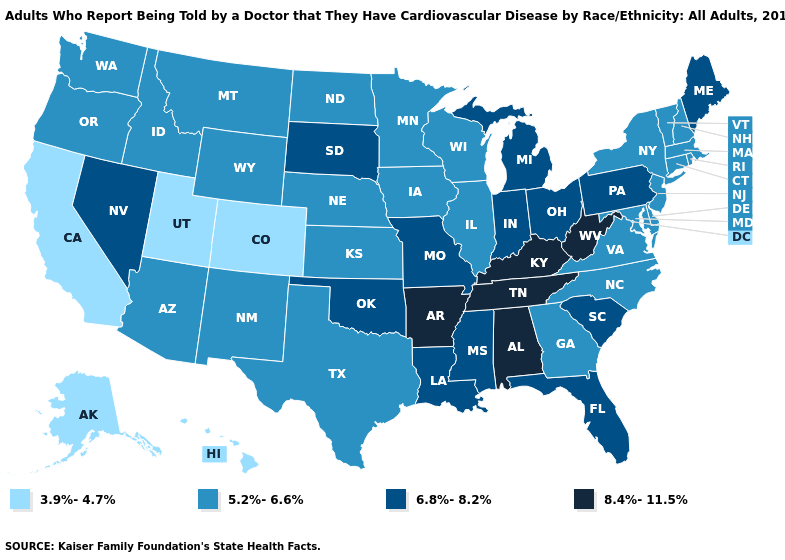Does the first symbol in the legend represent the smallest category?
Concise answer only. Yes. What is the highest value in states that border Michigan?
Give a very brief answer. 6.8%-8.2%. Does Texas have the same value as Indiana?
Write a very short answer. No. Name the states that have a value in the range 5.2%-6.6%?
Keep it brief. Arizona, Connecticut, Delaware, Georgia, Idaho, Illinois, Iowa, Kansas, Maryland, Massachusetts, Minnesota, Montana, Nebraska, New Hampshire, New Jersey, New Mexico, New York, North Carolina, North Dakota, Oregon, Rhode Island, Texas, Vermont, Virginia, Washington, Wisconsin, Wyoming. Name the states that have a value in the range 8.4%-11.5%?
Keep it brief. Alabama, Arkansas, Kentucky, Tennessee, West Virginia. Does North Dakota have the lowest value in the USA?
Answer briefly. No. What is the value of Mississippi?
Short answer required. 6.8%-8.2%. What is the highest value in the West ?
Be succinct. 6.8%-8.2%. Does Hawaii have the lowest value in the West?
Short answer required. Yes. What is the value of Minnesota?
Quick response, please. 5.2%-6.6%. Does Colorado have the lowest value in the West?
Short answer required. Yes. What is the value of Ohio?
Answer briefly. 6.8%-8.2%. What is the value of Virginia?
Give a very brief answer. 5.2%-6.6%. Does Washington have the lowest value in the West?
Give a very brief answer. No. What is the value of Massachusetts?
Write a very short answer. 5.2%-6.6%. 